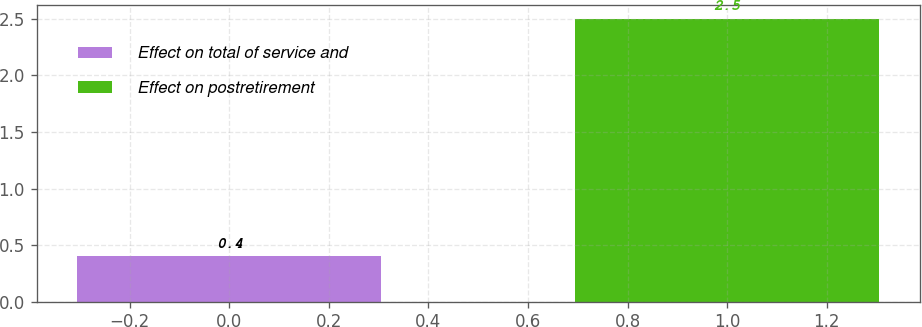<chart> <loc_0><loc_0><loc_500><loc_500><bar_chart><fcel>Effect on total of service and<fcel>Effect on postretirement<nl><fcel>0.4<fcel>2.5<nl></chart> 